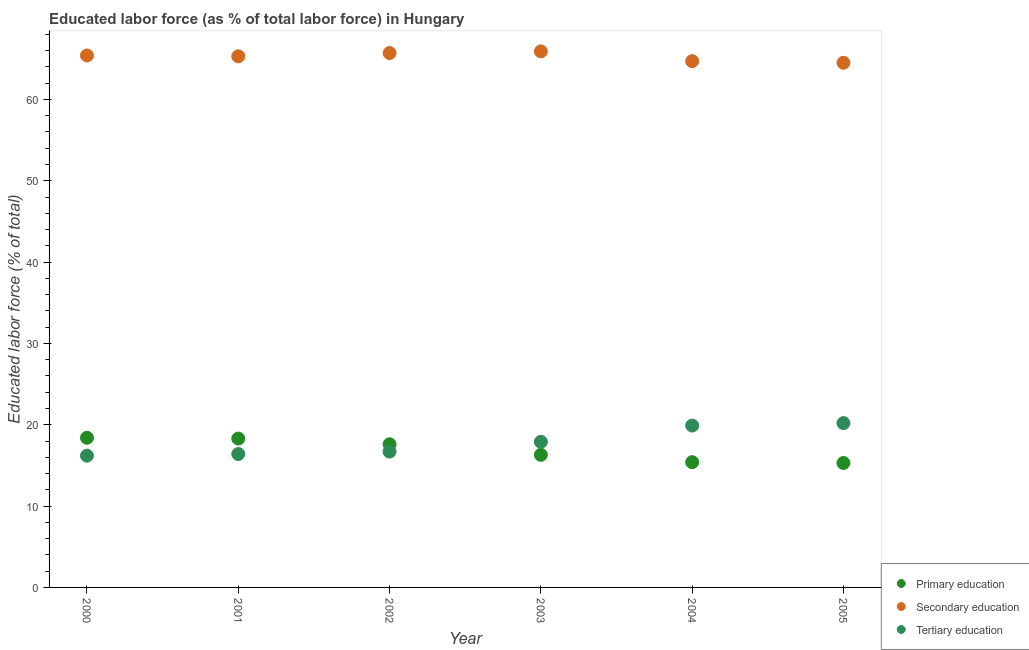How many different coloured dotlines are there?
Give a very brief answer. 3. Is the number of dotlines equal to the number of legend labels?
Your answer should be compact. Yes. What is the percentage of labor force who received secondary education in 2005?
Your response must be concise. 64.5. Across all years, what is the maximum percentage of labor force who received tertiary education?
Your response must be concise. 20.2. Across all years, what is the minimum percentage of labor force who received primary education?
Keep it short and to the point. 15.3. In which year was the percentage of labor force who received primary education minimum?
Offer a very short reply. 2005. What is the total percentage of labor force who received secondary education in the graph?
Give a very brief answer. 391.5. What is the difference between the percentage of labor force who received primary education in 2000 and that in 2002?
Offer a very short reply. 0.8. What is the difference between the percentage of labor force who received secondary education in 2000 and the percentage of labor force who received tertiary education in 2005?
Offer a very short reply. 45.2. What is the average percentage of labor force who received tertiary education per year?
Provide a succinct answer. 17.88. In the year 2001, what is the difference between the percentage of labor force who received secondary education and percentage of labor force who received tertiary education?
Your answer should be very brief. 48.9. In how many years, is the percentage of labor force who received tertiary education greater than 52 %?
Give a very brief answer. 0. What is the ratio of the percentage of labor force who received tertiary education in 2000 to that in 2003?
Your answer should be compact. 0.91. Is the percentage of labor force who received primary education in 2001 less than that in 2005?
Keep it short and to the point. No. Is the difference between the percentage of labor force who received secondary education in 2004 and 2005 greater than the difference between the percentage of labor force who received primary education in 2004 and 2005?
Ensure brevity in your answer.  Yes. What is the difference between the highest and the second highest percentage of labor force who received primary education?
Your response must be concise. 0.1. What is the difference between the highest and the lowest percentage of labor force who received primary education?
Make the answer very short. 3.1. In how many years, is the percentage of labor force who received primary education greater than the average percentage of labor force who received primary education taken over all years?
Keep it short and to the point. 3. Does the percentage of labor force who received tertiary education monotonically increase over the years?
Provide a short and direct response. Yes. Is the percentage of labor force who received primary education strictly less than the percentage of labor force who received tertiary education over the years?
Keep it short and to the point. No. How many years are there in the graph?
Your answer should be compact. 6. Are the values on the major ticks of Y-axis written in scientific E-notation?
Offer a terse response. No. Does the graph contain grids?
Your response must be concise. No. Where does the legend appear in the graph?
Keep it short and to the point. Bottom right. How many legend labels are there?
Offer a very short reply. 3. How are the legend labels stacked?
Your answer should be compact. Vertical. What is the title of the graph?
Make the answer very short. Educated labor force (as % of total labor force) in Hungary. What is the label or title of the Y-axis?
Your response must be concise. Educated labor force (% of total). What is the Educated labor force (% of total) in Primary education in 2000?
Keep it short and to the point. 18.4. What is the Educated labor force (% of total) in Secondary education in 2000?
Your response must be concise. 65.4. What is the Educated labor force (% of total) of Tertiary education in 2000?
Your answer should be compact. 16.2. What is the Educated labor force (% of total) in Primary education in 2001?
Your response must be concise. 18.3. What is the Educated labor force (% of total) in Secondary education in 2001?
Offer a terse response. 65.3. What is the Educated labor force (% of total) of Tertiary education in 2001?
Ensure brevity in your answer.  16.4. What is the Educated labor force (% of total) in Primary education in 2002?
Your answer should be compact. 17.6. What is the Educated labor force (% of total) of Secondary education in 2002?
Give a very brief answer. 65.7. What is the Educated labor force (% of total) in Tertiary education in 2002?
Your response must be concise. 16.7. What is the Educated labor force (% of total) of Primary education in 2003?
Your answer should be very brief. 16.3. What is the Educated labor force (% of total) in Secondary education in 2003?
Offer a terse response. 65.9. What is the Educated labor force (% of total) of Tertiary education in 2003?
Provide a succinct answer. 17.9. What is the Educated labor force (% of total) of Primary education in 2004?
Offer a very short reply. 15.4. What is the Educated labor force (% of total) of Secondary education in 2004?
Offer a terse response. 64.7. What is the Educated labor force (% of total) in Tertiary education in 2004?
Keep it short and to the point. 19.9. What is the Educated labor force (% of total) of Primary education in 2005?
Your answer should be compact. 15.3. What is the Educated labor force (% of total) of Secondary education in 2005?
Keep it short and to the point. 64.5. What is the Educated labor force (% of total) of Tertiary education in 2005?
Your response must be concise. 20.2. Across all years, what is the maximum Educated labor force (% of total) in Primary education?
Your answer should be compact. 18.4. Across all years, what is the maximum Educated labor force (% of total) in Secondary education?
Provide a short and direct response. 65.9. Across all years, what is the maximum Educated labor force (% of total) of Tertiary education?
Give a very brief answer. 20.2. Across all years, what is the minimum Educated labor force (% of total) in Primary education?
Your answer should be very brief. 15.3. Across all years, what is the minimum Educated labor force (% of total) of Secondary education?
Your answer should be very brief. 64.5. Across all years, what is the minimum Educated labor force (% of total) in Tertiary education?
Your answer should be compact. 16.2. What is the total Educated labor force (% of total) of Primary education in the graph?
Give a very brief answer. 101.3. What is the total Educated labor force (% of total) of Secondary education in the graph?
Ensure brevity in your answer.  391.5. What is the total Educated labor force (% of total) in Tertiary education in the graph?
Provide a succinct answer. 107.3. What is the difference between the Educated labor force (% of total) in Secondary education in 2000 and that in 2002?
Keep it short and to the point. -0.3. What is the difference between the Educated labor force (% of total) of Tertiary education in 2000 and that in 2002?
Offer a very short reply. -0.5. What is the difference between the Educated labor force (% of total) in Primary education in 2000 and that in 2003?
Provide a short and direct response. 2.1. What is the difference between the Educated labor force (% of total) of Tertiary education in 2000 and that in 2003?
Make the answer very short. -1.7. What is the difference between the Educated labor force (% of total) of Tertiary education in 2000 and that in 2004?
Ensure brevity in your answer.  -3.7. What is the difference between the Educated labor force (% of total) in Secondary education in 2000 and that in 2005?
Offer a very short reply. 0.9. What is the difference between the Educated labor force (% of total) of Tertiary education in 2000 and that in 2005?
Your response must be concise. -4. What is the difference between the Educated labor force (% of total) in Primary education in 2001 and that in 2002?
Ensure brevity in your answer.  0.7. What is the difference between the Educated labor force (% of total) in Tertiary education in 2001 and that in 2002?
Offer a very short reply. -0.3. What is the difference between the Educated labor force (% of total) in Primary education in 2001 and that in 2003?
Keep it short and to the point. 2. What is the difference between the Educated labor force (% of total) in Tertiary education in 2001 and that in 2003?
Make the answer very short. -1.5. What is the difference between the Educated labor force (% of total) in Secondary education in 2001 and that in 2004?
Keep it short and to the point. 0.6. What is the difference between the Educated labor force (% of total) of Tertiary education in 2001 and that in 2005?
Your response must be concise. -3.8. What is the difference between the Educated labor force (% of total) of Tertiary education in 2002 and that in 2003?
Ensure brevity in your answer.  -1.2. What is the difference between the Educated labor force (% of total) in Primary education in 2003 and that in 2004?
Offer a very short reply. 0.9. What is the difference between the Educated labor force (% of total) of Primary education in 2003 and that in 2005?
Keep it short and to the point. 1. What is the difference between the Educated labor force (% of total) of Primary education in 2004 and that in 2005?
Offer a terse response. 0.1. What is the difference between the Educated labor force (% of total) of Secondary education in 2004 and that in 2005?
Make the answer very short. 0.2. What is the difference between the Educated labor force (% of total) of Tertiary education in 2004 and that in 2005?
Give a very brief answer. -0.3. What is the difference between the Educated labor force (% of total) of Primary education in 2000 and the Educated labor force (% of total) of Secondary education in 2001?
Offer a very short reply. -46.9. What is the difference between the Educated labor force (% of total) in Primary education in 2000 and the Educated labor force (% of total) in Tertiary education in 2001?
Your answer should be compact. 2. What is the difference between the Educated labor force (% of total) in Secondary education in 2000 and the Educated labor force (% of total) in Tertiary education in 2001?
Your response must be concise. 49. What is the difference between the Educated labor force (% of total) of Primary education in 2000 and the Educated labor force (% of total) of Secondary education in 2002?
Ensure brevity in your answer.  -47.3. What is the difference between the Educated labor force (% of total) of Secondary education in 2000 and the Educated labor force (% of total) of Tertiary education in 2002?
Offer a very short reply. 48.7. What is the difference between the Educated labor force (% of total) in Primary education in 2000 and the Educated labor force (% of total) in Secondary education in 2003?
Give a very brief answer. -47.5. What is the difference between the Educated labor force (% of total) of Secondary education in 2000 and the Educated labor force (% of total) of Tertiary education in 2003?
Your answer should be compact. 47.5. What is the difference between the Educated labor force (% of total) of Primary education in 2000 and the Educated labor force (% of total) of Secondary education in 2004?
Your answer should be compact. -46.3. What is the difference between the Educated labor force (% of total) in Secondary education in 2000 and the Educated labor force (% of total) in Tertiary education in 2004?
Provide a short and direct response. 45.5. What is the difference between the Educated labor force (% of total) in Primary education in 2000 and the Educated labor force (% of total) in Secondary education in 2005?
Offer a terse response. -46.1. What is the difference between the Educated labor force (% of total) of Secondary education in 2000 and the Educated labor force (% of total) of Tertiary education in 2005?
Make the answer very short. 45.2. What is the difference between the Educated labor force (% of total) in Primary education in 2001 and the Educated labor force (% of total) in Secondary education in 2002?
Your answer should be compact. -47.4. What is the difference between the Educated labor force (% of total) in Primary education in 2001 and the Educated labor force (% of total) in Tertiary education in 2002?
Offer a very short reply. 1.6. What is the difference between the Educated labor force (% of total) in Secondary education in 2001 and the Educated labor force (% of total) in Tertiary education in 2002?
Ensure brevity in your answer.  48.6. What is the difference between the Educated labor force (% of total) in Primary education in 2001 and the Educated labor force (% of total) in Secondary education in 2003?
Keep it short and to the point. -47.6. What is the difference between the Educated labor force (% of total) of Secondary education in 2001 and the Educated labor force (% of total) of Tertiary education in 2003?
Your answer should be very brief. 47.4. What is the difference between the Educated labor force (% of total) of Primary education in 2001 and the Educated labor force (% of total) of Secondary education in 2004?
Give a very brief answer. -46.4. What is the difference between the Educated labor force (% of total) of Secondary education in 2001 and the Educated labor force (% of total) of Tertiary education in 2004?
Give a very brief answer. 45.4. What is the difference between the Educated labor force (% of total) of Primary education in 2001 and the Educated labor force (% of total) of Secondary education in 2005?
Offer a very short reply. -46.2. What is the difference between the Educated labor force (% of total) in Secondary education in 2001 and the Educated labor force (% of total) in Tertiary education in 2005?
Give a very brief answer. 45.1. What is the difference between the Educated labor force (% of total) in Primary education in 2002 and the Educated labor force (% of total) in Secondary education in 2003?
Your response must be concise. -48.3. What is the difference between the Educated labor force (% of total) in Primary education in 2002 and the Educated labor force (% of total) in Tertiary education in 2003?
Offer a very short reply. -0.3. What is the difference between the Educated labor force (% of total) in Secondary education in 2002 and the Educated labor force (% of total) in Tertiary education in 2003?
Ensure brevity in your answer.  47.8. What is the difference between the Educated labor force (% of total) in Primary education in 2002 and the Educated labor force (% of total) in Secondary education in 2004?
Offer a very short reply. -47.1. What is the difference between the Educated labor force (% of total) of Primary education in 2002 and the Educated labor force (% of total) of Tertiary education in 2004?
Provide a succinct answer. -2.3. What is the difference between the Educated labor force (% of total) of Secondary education in 2002 and the Educated labor force (% of total) of Tertiary education in 2004?
Your response must be concise. 45.8. What is the difference between the Educated labor force (% of total) in Primary education in 2002 and the Educated labor force (% of total) in Secondary education in 2005?
Ensure brevity in your answer.  -46.9. What is the difference between the Educated labor force (% of total) of Secondary education in 2002 and the Educated labor force (% of total) of Tertiary education in 2005?
Provide a short and direct response. 45.5. What is the difference between the Educated labor force (% of total) of Primary education in 2003 and the Educated labor force (% of total) of Secondary education in 2004?
Your response must be concise. -48.4. What is the difference between the Educated labor force (% of total) in Primary education in 2003 and the Educated labor force (% of total) in Tertiary education in 2004?
Your answer should be compact. -3.6. What is the difference between the Educated labor force (% of total) of Primary education in 2003 and the Educated labor force (% of total) of Secondary education in 2005?
Your answer should be compact. -48.2. What is the difference between the Educated labor force (% of total) in Secondary education in 2003 and the Educated labor force (% of total) in Tertiary education in 2005?
Give a very brief answer. 45.7. What is the difference between the Educated labor force (% of total) in Primary education in 2004 and the Educated labor force (% of total) in Secondary education in 2005?
Give a very brief answer. -49.1. What is the difference between the Educated labor force (% of total) in Primary education in 2004 and the Educated labor force (% of total) in Tertiary education in 2005?
Your answer should be compact. -4.8. What is the difference between the Educated labor force (% of total) in Secondary education in 2004 and the Educated labor force (% of total) in Tertiary education in 2005?
Make the answer very short. 44.5. What is the average Educated labor force (% of total) in Primary education per year?
Make the answer very short. 16.88. What is the average Educated labor force (% of total) of Secondary education per year?
Your answer should be very brief. 65.25. What is the average Educated labor force (% of total) of Tertiary education per year?
Your answer should be very brief. 17.88. In the year 2000, what is the difference between the Educated labor force (% of total) in Primary education and Educated labor force (% of total) in Secondary education?
Ensure brevity in your answer.  -47. In the year 2000, what is the difference between the Educated labor force (% of total) of Secondary education and Educated labor force (% of total) of Tertiary education?
Offer a terse response. 49.2. In the year 2001, what is the difference between the Educated labor force (% of total) in Primary education and Educated labor force (% of total) in Secondary education?
Your response must be concise. -47. In the year 2001, what is the difference between the Educated labor force (% of total) in Secondary education and Educated labor force (% of total) in Tertiary education?
Provide a succinct answer. 48.9. In the year 2002, what is the difference between the Educated labor force (% of total) in Primary education and Educated labor force (% of total) in Secondary education?
Keep it short and to the point. -48.1. In the year 2002, what is the difference between the Educated labor force (% of total) of Secondary education and Educated labor force (% of total) of Tertiary education?
Offer a terse response. 49. In the year 2003, what is the difference between the Educated labor force (% of total) of Primary education and Educated labor force (% of total) of Secondary education?
Provide a succinct answer. -49.6. In the year 2003, what is the difference between the Educated labor force (% of total) of Secondary education and Educated labor force (% of total) of Tertiary education?
Ensure brevity in your answer.  48. In the year 2004, what is the difference between the Educated labor force (% of total) in Primary education and Educated labor force (% of total) in Secondary education?
Offer a very short reply. -49.3. In the year 2004, what is the difference between the Educated labor force (% of total) of Primary education and Educated labor force (% of total) of Tertiary education?
Offer a very short reply. -4.5. In the year 2004, what is the difference between the Educated labor force (% of total) in Secondary education and Educated labor force (% of total) in Tertiary education?
Provide a short and direct response. 44.8. In the year 2005, what is the difference between the Educated labor force (% of total) in Primary education and Educated labor force (% of total) in Secondary education?
Provide a short and direct response. -49.2. In the year 2005, what is the difference between the Educated labor force (% of total) of Secondary education and Educated labor force (% of total) of Tertiary education?
Make the answer very short. 44.3. What is the ratio of the Educated labor force (% of total) in Tertiary education in 2000 to that in 2001?
Provide a succinct answer. 0.99. What is the ratio of the Educated labor force (% of total) in Primary education in 2000 to that in 2002?
Offer a very short reply. 1.05. What is the ratio of the Educated labor force (% of total) of Tertiary education in 2000 to that in 2002?
Your answer should be compact. 0.97. What is the ratio of the Educated labor force (% of total) of Primary education in 2000 to that in 2003?
Ensure brevity in your answer.  1.13. What is the ratio of the Educated labor force (% of total) in Secondary education in 2000 to that in 2003?
Ensure brevity in your answer.  0.99. What is the ratio of the Educated labor force (% of total) of Tertiary education in 2000 to that in 2003?
Your response must be concise. 0.91. What is the ratio of the Educated labor force (% of total) in Primary education in 2000 to that in 2004?
Your answer should be very brief. 1.19. What is the ratio of the Educated labor force (% of total) in Secondary education in 2000 to that in 2004?
Your response must be concise. 1.01. What is the ratio of the Educated labor force (% of total) of Tertiary education in 2000 to that in 2004?
Make the answer very short. 0.81. What is the ratio of the Educated labor force (% of total) of Primary education in 2000 to that in 2005?
Your answer should be very brief. 1.2. What is the ratio of the Educated labor force (% of total) of Tertiary education in 2000 to that in 2005?
Make the answer very short. 0.8. What is the ratio of the Educated labor force (% of total) in Primary education in 2001 to that in 2002?
Your answer should be compact. 1.04. What is the ratio of the Educated labor force (% of total) in Secondary education in 2001 to that in 2002?
Provide a short and direct response. 0.99. What is the ratio of the Educated labor force (% of total) in Tertiary education in 2001 to that in 2002?
Give a very brief answer. 0.98. What is the ratio of the Educated labor force (% of total) in Primary education in 2001 to that in 2003?
Your answer should be very brief. 1.12. What is the ratio of the Educated labor force (% of total) of Secondary education in 2001 to that in 2003?
Ensure brevity in your answer.  0.99. What is the ratio of the Educated labor force (% of total) in Tertiary education in 2001 to that in 2003?
Provide a short and direct response. 0.92. What is the ratio of the Educated labor force (% of total) in Primary education in 2001 to that in 2004?
Offer a terse response. 1.19. What is the ratio of the Educated labor force (% of total) in Secondary education in 2001 to that in 2004?
Ensure brevity in your answer.  1.01. What is the ratio of the Educated labor force (% of total) in Tertiary education in 2001 to that in 2004?
Offer a very short reply. 0.82. What is the ratio of the Educated labor force (% of total) in Primary education in 2001 to that in 2005?
Your answer should be very brief. 1.2. What is the ratio of the Educated labor force (% of total) in Secondary education in 2001 to that in 2005?
Provide a short and direct response. 1.01. What is the ratio of the Educated labor force (% of total) in Tertiary education in 2001 to that in 2005?
Provide a short and direct response. 0.81. What is the ratio of the Educated labor force (% of total) of Primary education in 2002 to that in 2003?
Provide a short and direct response. 1.08. What is the ratio of the Educated labor force (% of total) in Tertiary education in 2002 to that in 2003?
Offer a terse response. 0.93. What is the ratio of the Educated labor force (% of total) in Primary education in 2002 to that in 2004?
Offer a terse response. 1.14. What is the ratio of the Educated labor force (% of total) in Secondary education in 2002 to that in 2004?
Ensure brevity in your answer.  1.02. What is the ratio of the Educated labor force (% of total) in Tertiary education in 2002 to that in 2004?
Provide a succinct answer. 0.84. What is the ratio of the Educated labor force (% of total) in Primary education in 2002 to that in 2005?
Provide a short and direct response. 1.15. What is the ratio of the Educated labor force (% of total) in Secondary education in 2002 to that in 2005?
Give a very brief answer. 1.02. What is the ratio of the Educated labor force (% of total) of Tertiary education in 2002 to that in 2005?
Offer a terse response. 0.83. What is the ratio of the Educated labor force (% of total) in Primary education in 2003 to that in 2004?
Your answer should be compact. 1.06. What is the ratio of the Educated labor force (% of total) in Secondary education in 2003 to that in 2004?
Offer a very short reply. 1.02. What is the ratio of the Educated labor force (% of total) of Tertiary education in 2003 to that in 2004?
Make the answer very short. 0.9. What is the ratio of the Educated labor force (% of total) in Primary education in 2003 to that in 2005?
Provide a succinct answer. 1.07. What is the ratio of the Educated labor force (% of total) in Secondary education in 2003 to that in 2005?
Offer a terse response. 1.02. What is the ratio of the Educated labor force (% of total) in Tertiary education in 2003 to that in 2005?
Give a very brief answer. 0.89. What is the ratio of the Educated labor force (% of total) of Primary education in 2004 to that in 2005?
Offer a very short reply. 1.01. What is the ratio of the Educated labor force (% of total) in Tertiary education in 2004 to that in 2005?
Provide a short and direct response. 0.99. What is the difference between the highest and the second highest Educated labor force (% of total) of Primary education?
Your response must be concise. 0.1. 